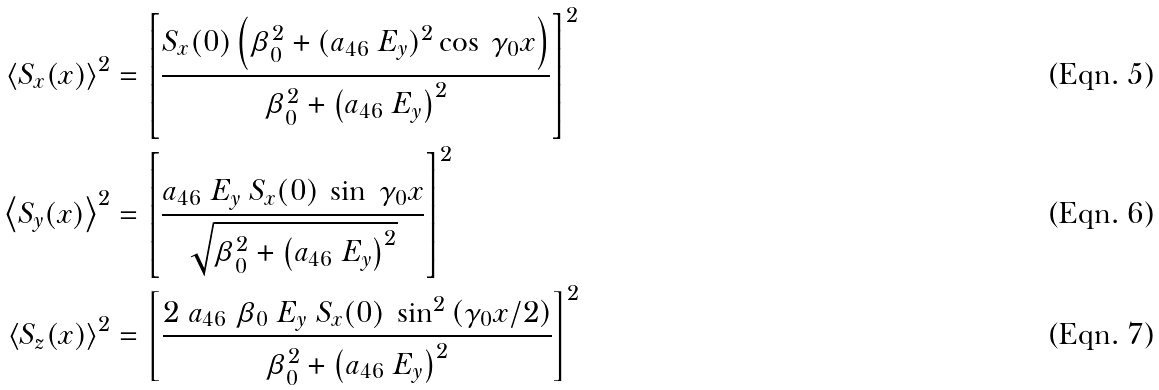<formula> <loc_0><loc_0><loc_500><loc_500>\left \langle S _ { x } ( x ) \right \rangle ^ { 2 } & = \left [ \frac { S _ { x } ( 0 ) \left ( \beta ^ { 2 } _ { 0 } + ( a _ { 4 6 } \ E _ { y } ) ^ { 2 } \cos \ \gamma _ { 0 } x \right ) } { \beta ^ { 2 } _ { 0 } + \left ( a _ { 4 6 } \ E _ { y } \right ) ^ { 2 } } \right ] ^ { 2 } \\ \left \langle S _ { y } ( x ) \right \rangle ^ { 2 } & = \left [ \frac { a _ { 4 6 } \ E _ { y } \ S _ { x } ( 0 ) \ \sin \ \gamma _ { 0 } x } { \sqrt { \beta ^ { 2 } _ { 0 } + \left ( a _ { 4 6 } \ E _ { y } \right ) ^ { 2 } } } \right ] ^ { 2 } \\ \left \langle S _ { z } ( x ) \right \rangle ^ { 2 } & = \left [ \frac { 2 \ a _ { 4 6 } \ \beta _ { 0 } \ E _ { y } \ S _ { x } ( 0 ) \ \sin ^ { 2 } \left ( \gamma _ { 0 } x / 2 \right ) } { \beta ^ { 2 } _ { 0 } + \left ( a _ { 4 6 } \ E _ { y } \right ) ^ { 2 } } \right ] ^ { 2 }</formula> 